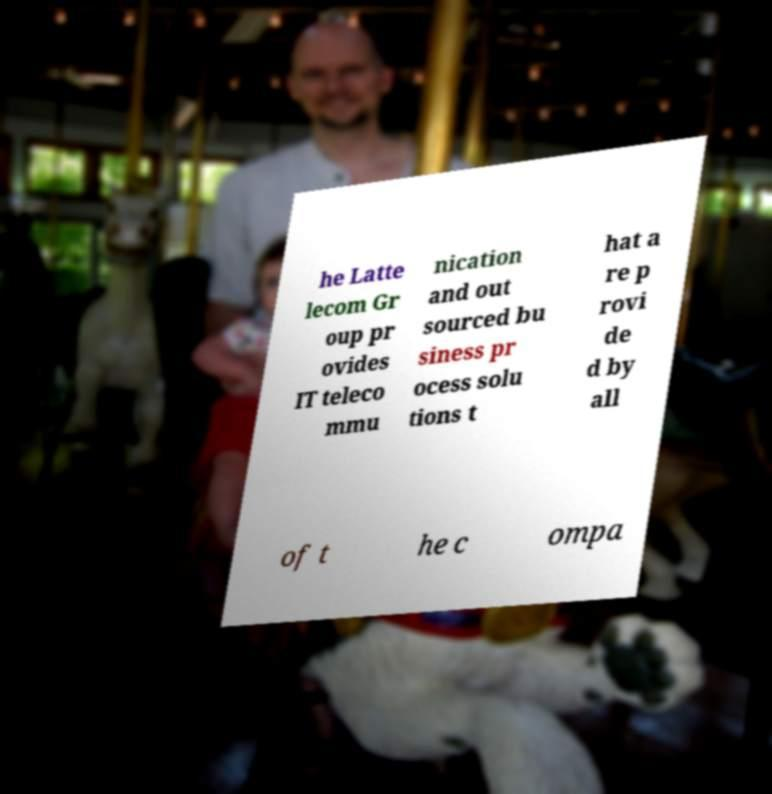What messages or text are displayed in this image? I need them in a readable, typed format. he Latte lecom Gr oup pr ovides IT teleco mmu nication and out sourced bu siness pr ocess solu tions t hat a re p rovi de d by all of t he c ompa 